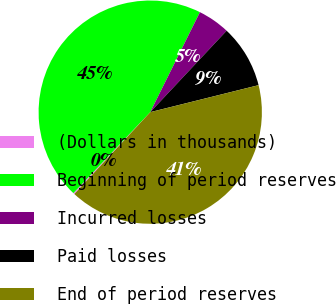Convert chart to OTSL. <chart><loc_0><loc_0><loc_500><loc_500><pie_chart><fcel>(Dollars in thousands)<fcel>Beginning of period reserves<fcel>Incurred losses<fcel>Paid losses<fcel>End of period reserves<nl><fcel>0.19%<fcel>45.25%<fcel>4.65%<fcel>9.12%<fcel>40.78%<nl></chart> 